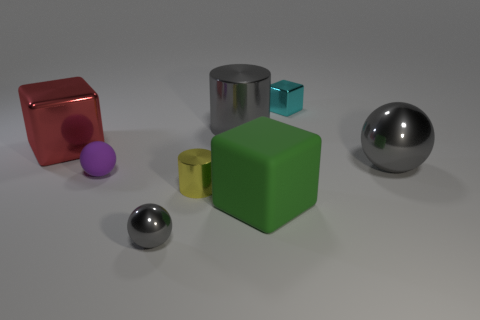What number of spheres have the same color as the large metal cylinder?
Offer a terse response. 2. Are any tiny gray shiny cylinders visible?
Offer a very short reply. No. What is the color of the big sphere that is the same material as the cyan cube?
Ensure brevity in your answer.  Gray. There is a tiny rubber ball that is left of the gray object in front of the metallic cylinder that is in front of the large red thing; what is its color?
Keep it short and to the point. Purple. Is the size of the purple object the same as the metallic cube that is on the left side of the purple rubber ball?
Keep it short and to the point. No. What number of things are cylinders that are in front of the purple sphere or blocks behind the large green rubber block?
Provide a short and direct response. 3. There is a green matte thing that is the same size as the red object; what is its shape?
Make the answer very short. Cube. What shape is the large metal object left of the small thing that is left of the small metallic object that is in front of the big green object?
Offer a very short reply. Cube. Are there an equal number of big gray balls that are in front of the tiny yellow metallic thing and cyan shiny cubes?
Ensure brevity in your answer.  No. Do the cyan metallic cube and the yellow cylinder have the same size?
Your answer should be compact. Yes. 